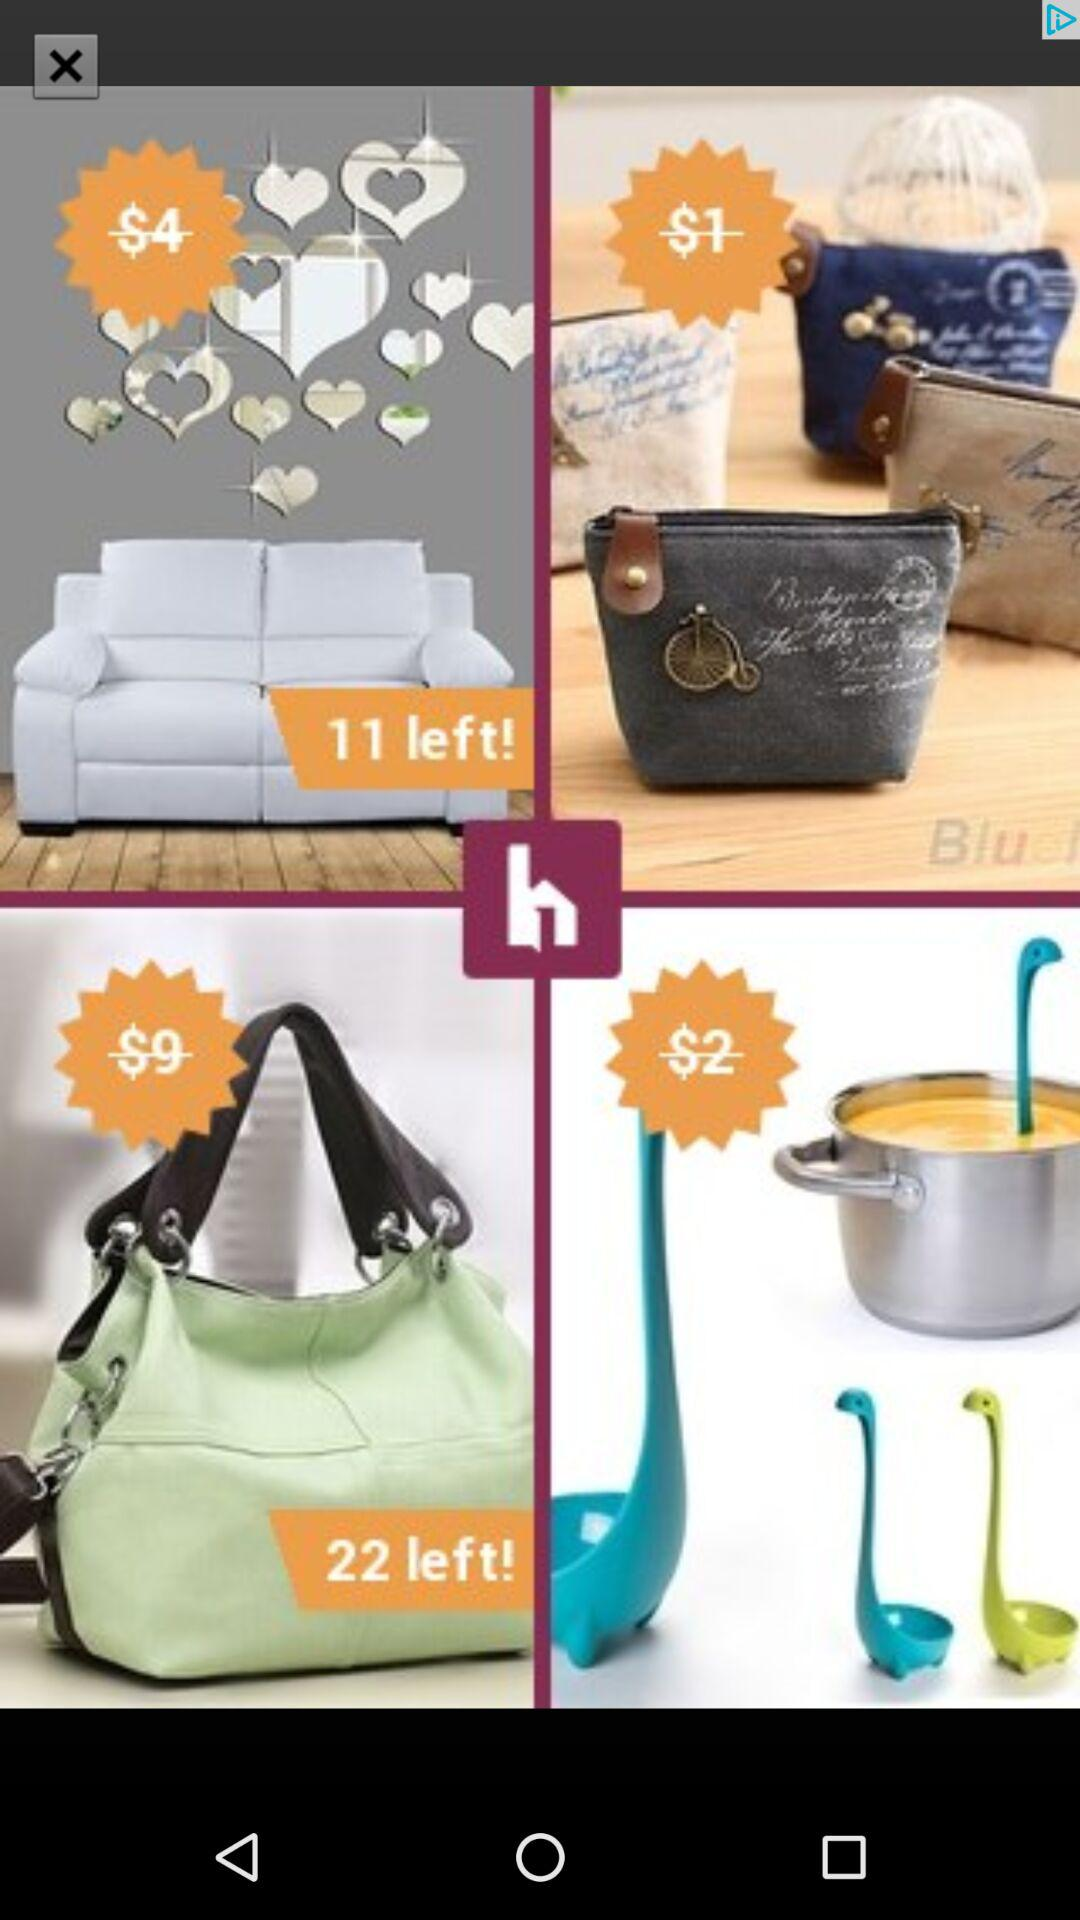How many items are in the cart?
Answer the question using a single word or phrase. 4 